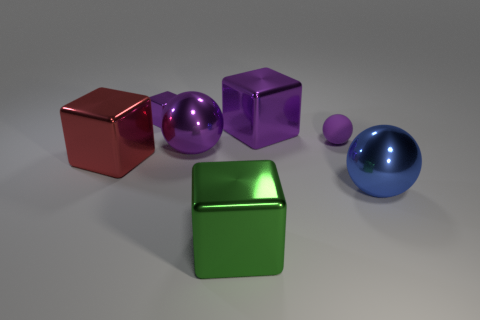How many big balls have the same material as the big green block?
Offer a terse response. 2. There is a large shiny object behind the purple matte object; how many cubes are left of it?
Offer a very short reply. 3. Are there any objects in front of the small purple metallic cube?
Keep it short and to the point. Yes. Do the big purple object left of the big green shiny block and the matte thing have the same shape?
Keep it short and to the point. Yes. There is a small sphere that is the same color as the tiny metal object; what is it made of?
Keep it short and to the point. Rubber. What number of tiny blocks have the same color as the small shiny object?
Keep it short and to the point. 0. There is a tiny object that is on the right side of the large sphere on the left side of the blue sphere; what shape is it?
Make the answer very short. Sphere. Are there any other green metallic things that have the same shape as the green shiny thing?
Provide a succinct answer. No. Do the tiny matte object and the big shiny ball behind the blue thing have the same color?
Give a very brief answer. Yes. There is a matte sphere that is the same color as the tiny shiny thing; what size is it?
Offer a very short reply. Small. 